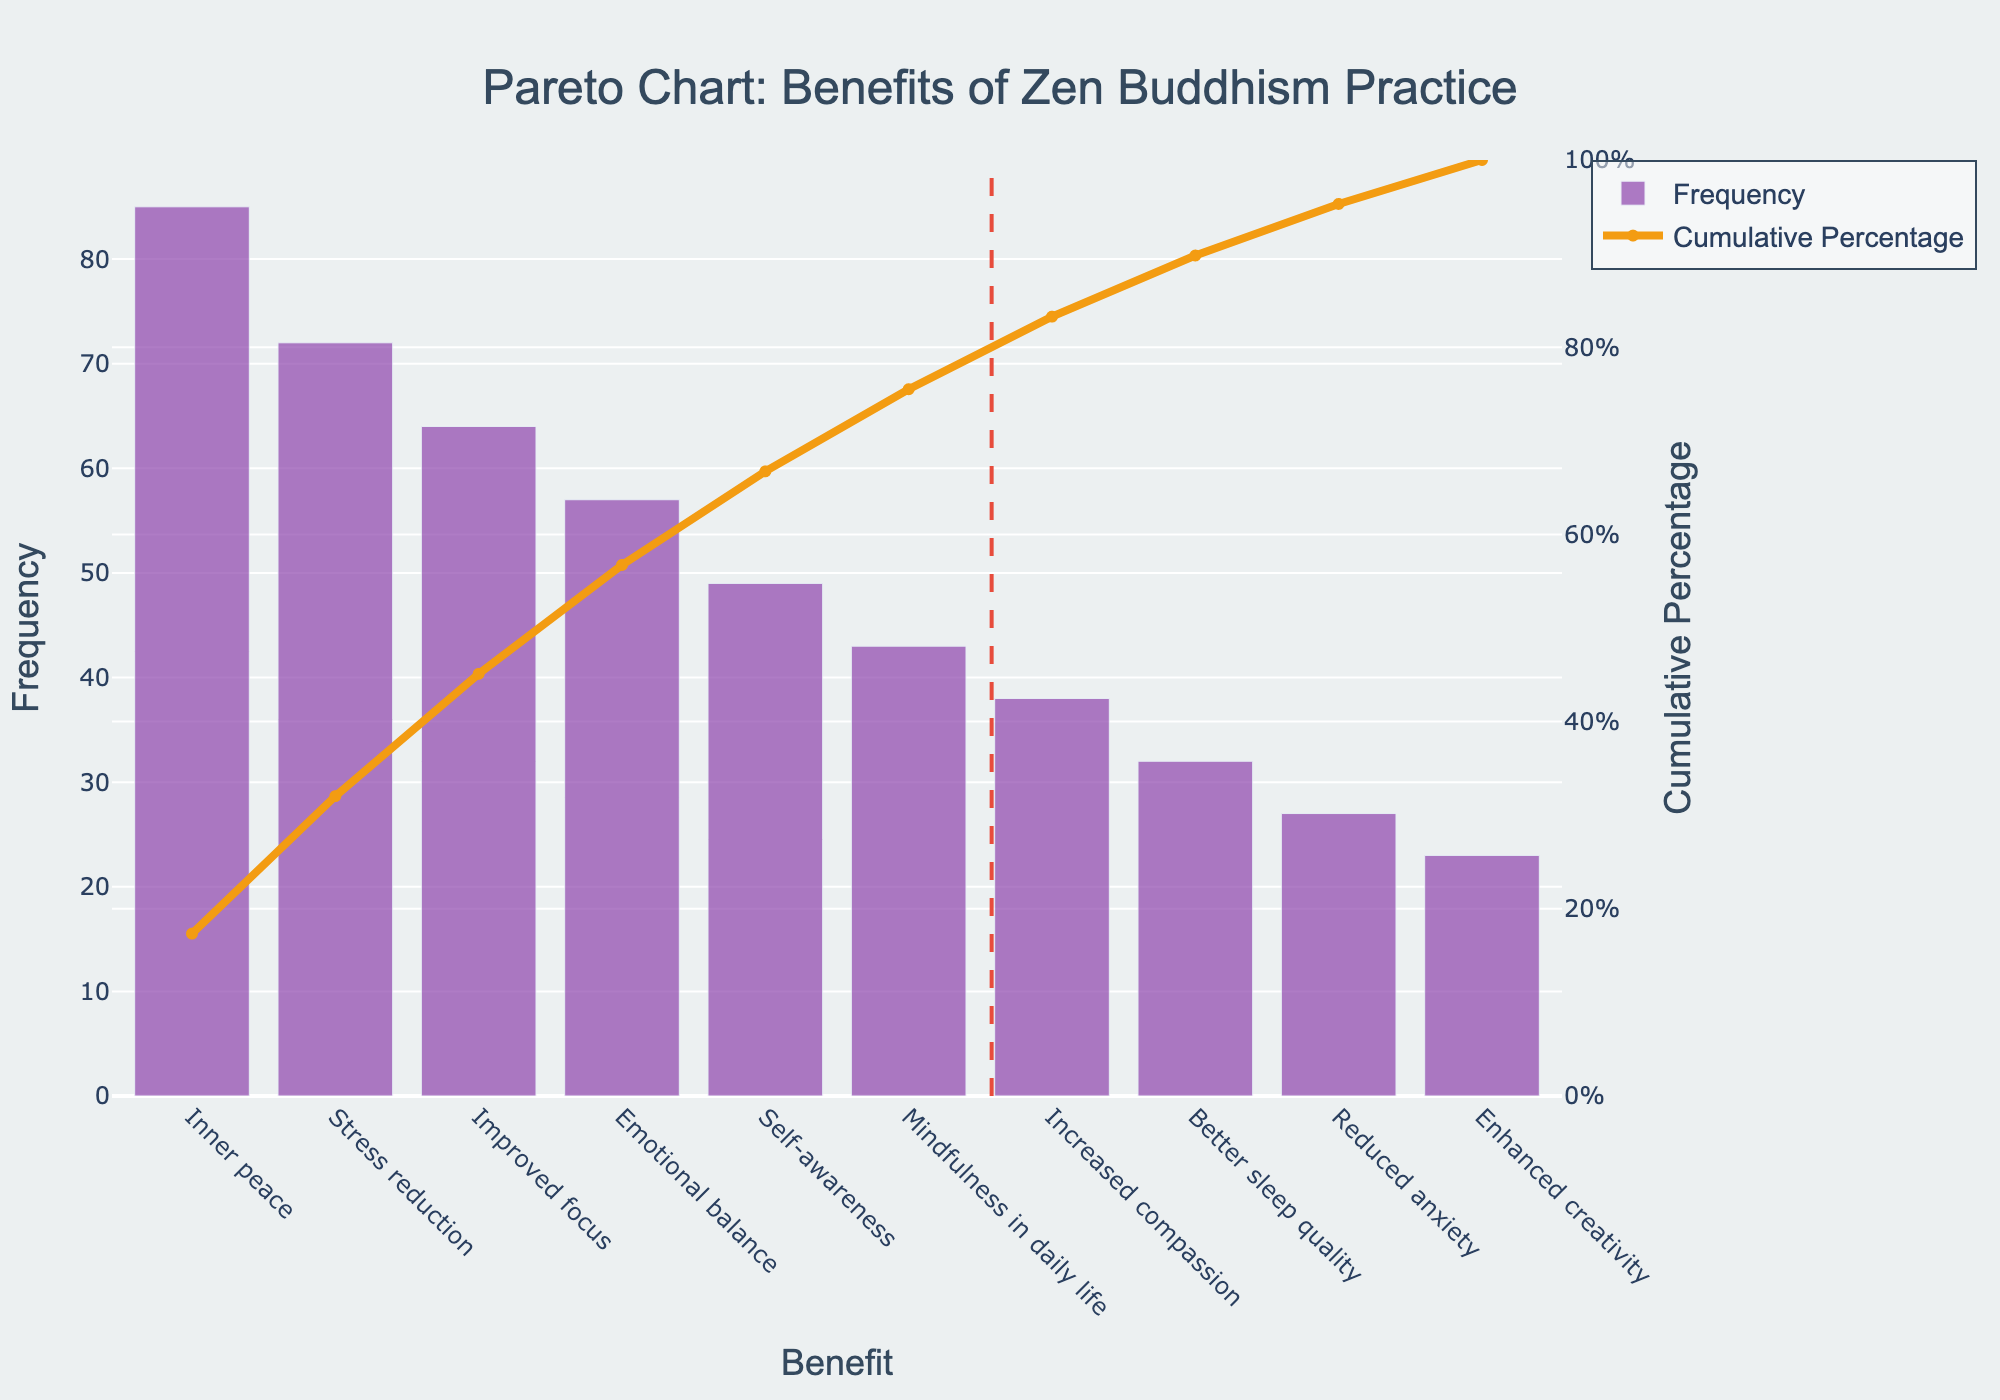What is the most frequently cited benefit of Zen Buddhism practice? The most frequently cited benefit of Zen Buddhism practice is located at the leftmost side of the Pareto chart. It has the highest bar height.
Answer: Inner peace Which benefit has the lowest frequency? The least frequently cited benefit of Zen Buddhism practice is located at the rightmost side of the Pareto chart. It has the shortest bar height.
Answer: Enhanced creativity How many benefits make up 80% of the cumulative percentage? To determine how many benefits make up 80% of the cumulative percentage, locate the 80% line on the secondary y-axis (Cumulative Percentage) and find the corresponding benefit count.
Answer: 6 benefits What is the cumulative percentage for 'Improved focus'? The cumulative percentage for 'Improved focus' can be identified by looking at the position of 'Improved focus' on the Pareto chart and tracing upwards to the line chart representing the cumulative percentage.
Answer: 67.2% By how much does 'Inner peace' exceed 'Better sleep quality' in frequency? 'Inner peace' frequency is 85, and 'Better sleep quality' frequency is 32. The difference is calculated by subtracting the frequency of 'Better sleep quality' from 'Inner peace'.
Answer: 53 Which two benefits, when combined, have a frequency close to that of 'Inner peace'? The combined frequency close to 'Inner peace' (85) can be estimated by adding the frequencies of 'Stress reduction' (72) and 'Reduced anxiety' (27). The closest combination would be considered.
Answer: Stress reduction and Reduced anxiety Is 'Self-awareness' more or less frequently cited than 'Emotional balance'? Compare the bar heights of 'Self-awareness' and 'Emotional balance' to see which one is higher.
Answer: Less frequently cited What is the cumulative percentage for the top three benefits combined? Sum the cumulative percentages of the top three benefits: 'Inner peace', 'Stress reduction', and 'Improved focus' by looking at their values on the cumulative percentage line.
Answer: 66.4% Which benefit shows a frequency precisely half that of 'Inner peace'? 'Inner peace' frequency is 85. The benefit with half its frequency would be 85/2 = 42.5. Find the benefit closest to this frequency.
Answer: Mindfulness in daily life 